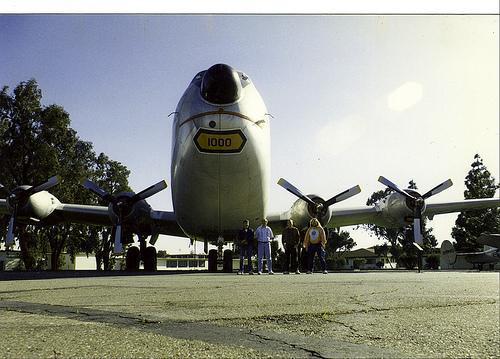How many propellers are visible?
Give a very brief answer. 4. How many people are standing under the plane?
Give a very brief answer. 4. 